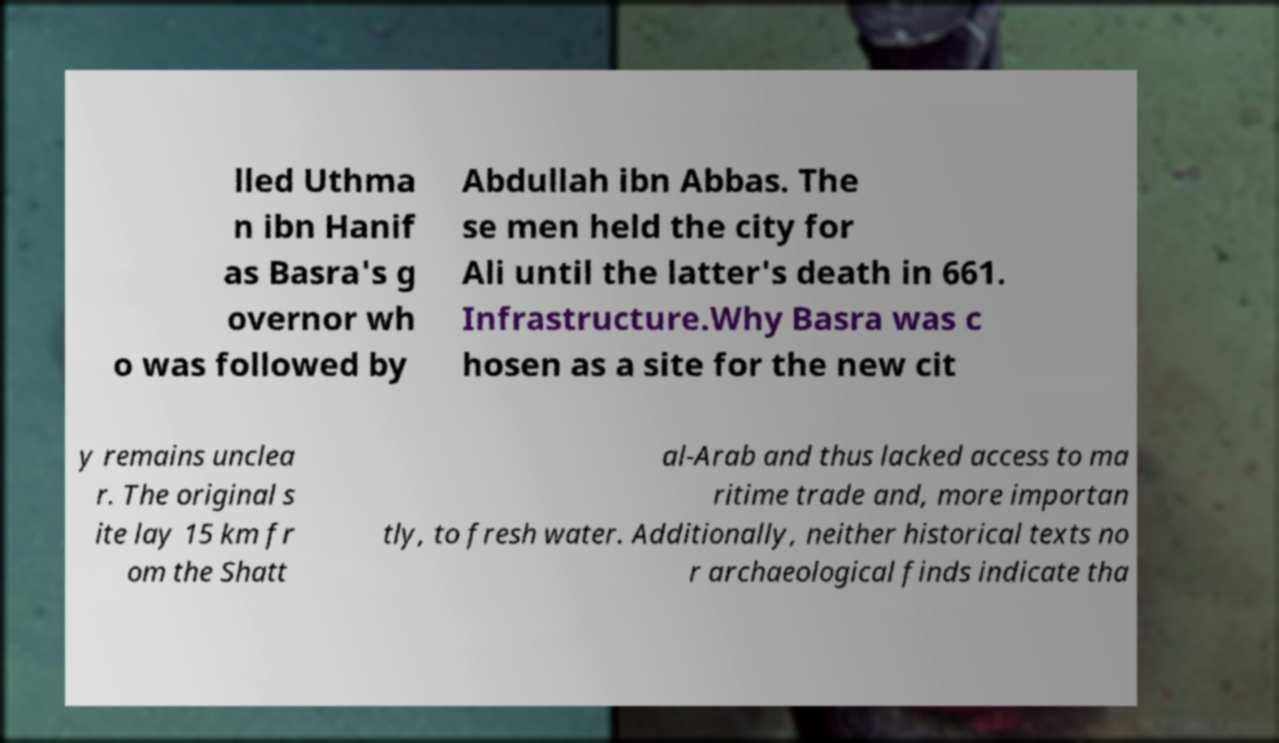Could you assist in decoding the text presented in this image and type it out clearly? lled Uthma n ibn Hanif as Basra's g overnor wh o was followed by Abdullah ibn Abbas. The se men held the city for Ali until the latter's death in 661. Infrastructure.Why Basra was c hosen as a site for the new cit y remains unclea r. The original s ite lay 15 km fr om the Shatt al-Arab and thus lacked access to ma ritime trade and, more importan tly, to fresh water. Additionally, neither historical texts no r archaeological finds indicate tha 